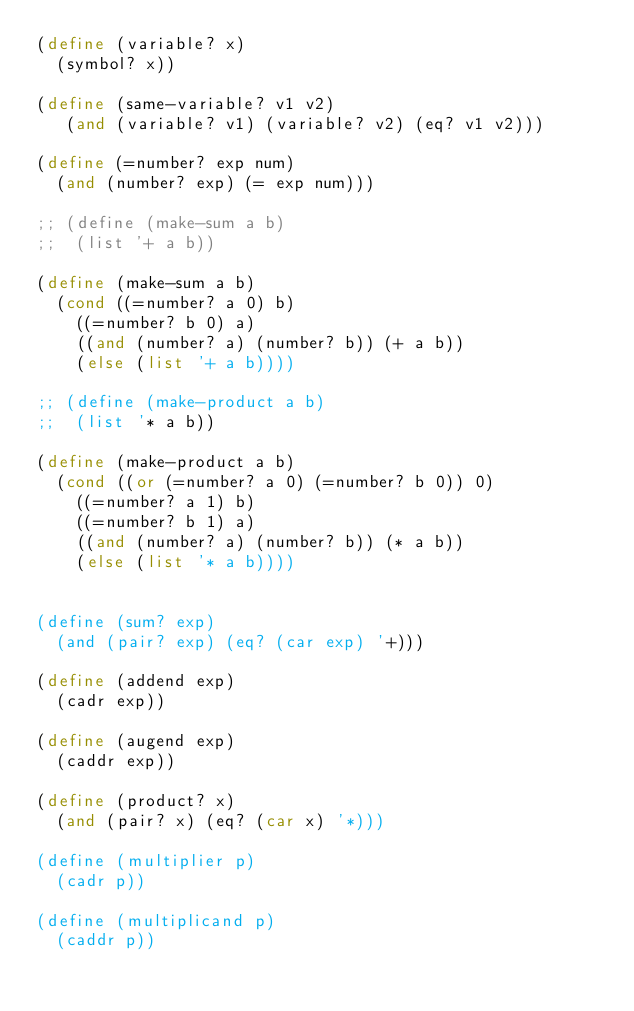Convert code to text. <code><loc_0><loc_0><loc_500><loc_500><_Scheme_>(define (variable? x)
  (symbol? x))

(define (same-variable? v1 v2)
   (and (variable? v1) (variable? v2) (eq? v1 v2)))

(define (=number? exp num)
  (and (number? exp) (= exp num))) 

;; (define (make-sum a b)
;;  (list '+ a b))

(define (make-sum a b)
  (cond ((=number? a 0) b)
	((=number? b 0) a)
	((and (number? a) (number? b)) (+ a b))
	(else (list '+ a b))))

;; (define (make-product a b)
;;  (list '* a b))

(define (make-product a b)
  (cond ((or (=number? a 0) (=number? b 0)) 0)
	((=number? a 1) b)
	((=number? b 1) a)
	((and (number? a) (number? b)) (* a b))
	(else (list '* a b))))


(define (sum? exp)
  (and (pair? exp) (eq? (car exp) '+)))

(define (addend exp)
  (cadr exp))

(define (augend exp)
  (caddr exp))

(define (product? x)
  (and (pair? x) (eq? (car x) '*)))

(define (multiplier p)
  (cadr p))

(define (multiplicand p)
  (caddr p))


</code> 